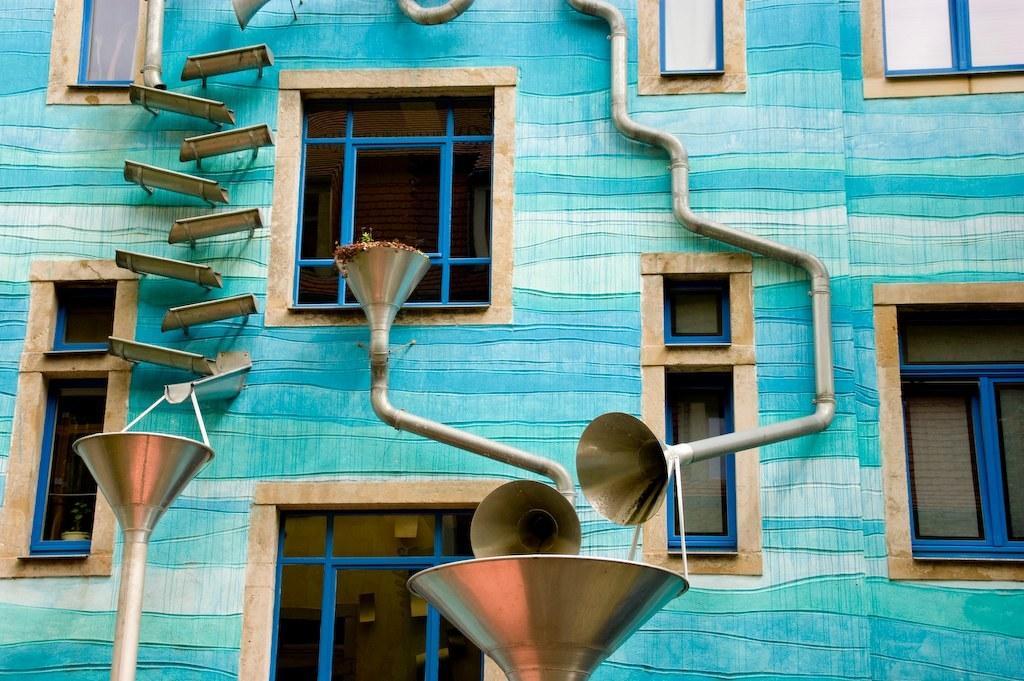Could you give a brief overview of what you see in this image? In this image we can see a building with windows. Also there are pipes. And there are some other items on the wall. Also there are funnel shaped objects. 